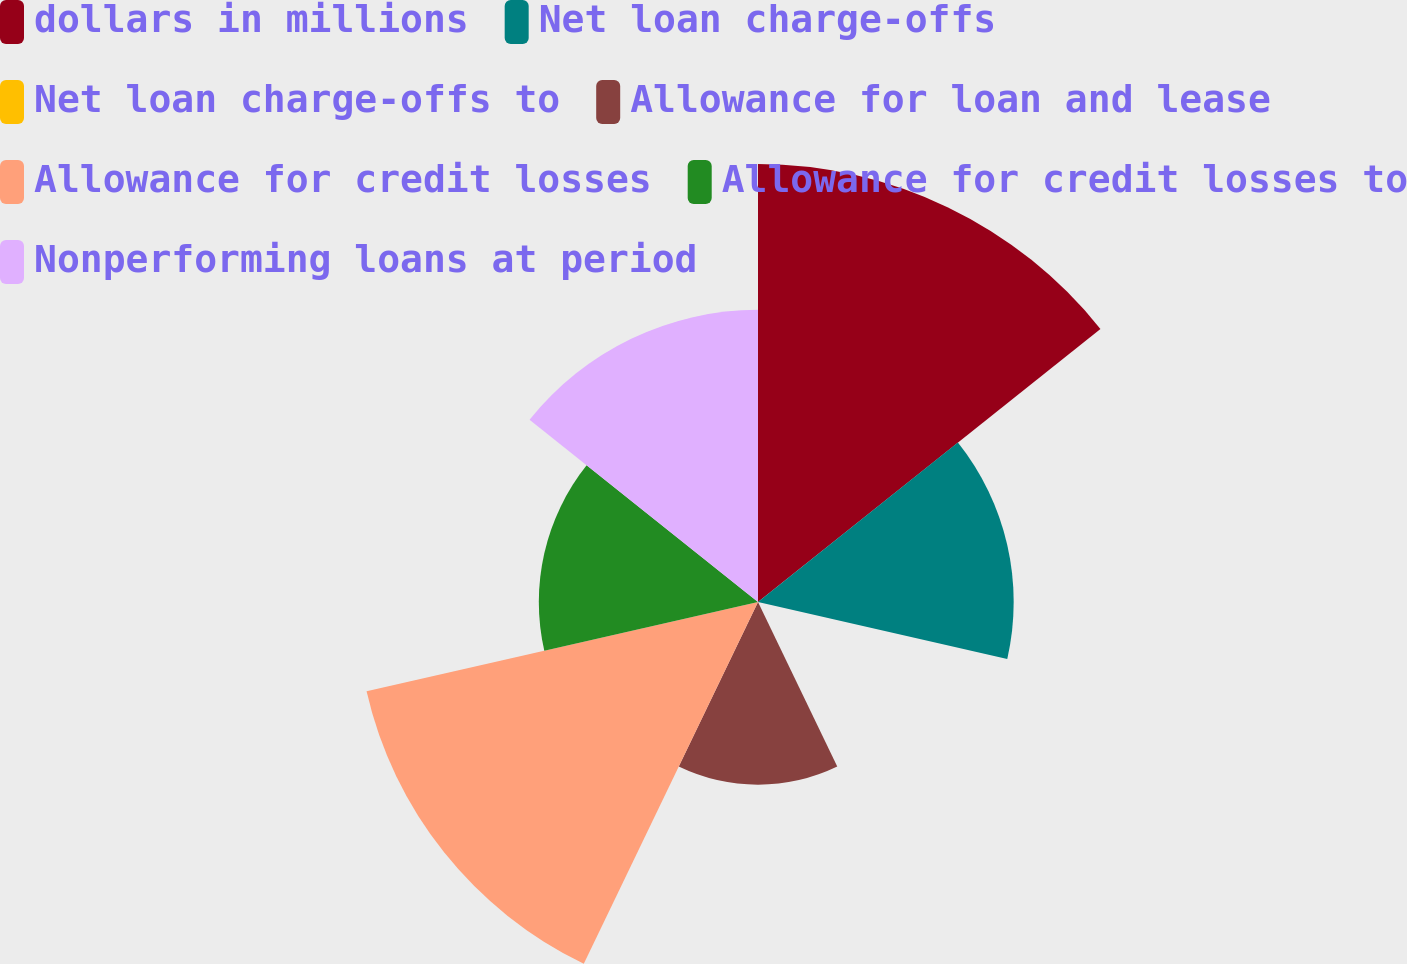Convert chart to OTSL. <chart><loc_0><loc_0><loc_500><loc_500><pie_chart><fcel>dollars in millions<fcel>Net loan charge-offs<fcel>Net loan charge-offs to<fcel>Allowance for loan and lease<fcel>Allowance for credit losses<fcel>Allowance for credit losses to<fcel>Nonperforming loans at period<nl><fcel>24.48%<fcel>14.29%<fcel>0.01%<fcel>10.21%<fcel>22.44%<fcel>12.25%<fcel>16.33%<nl></chart> 